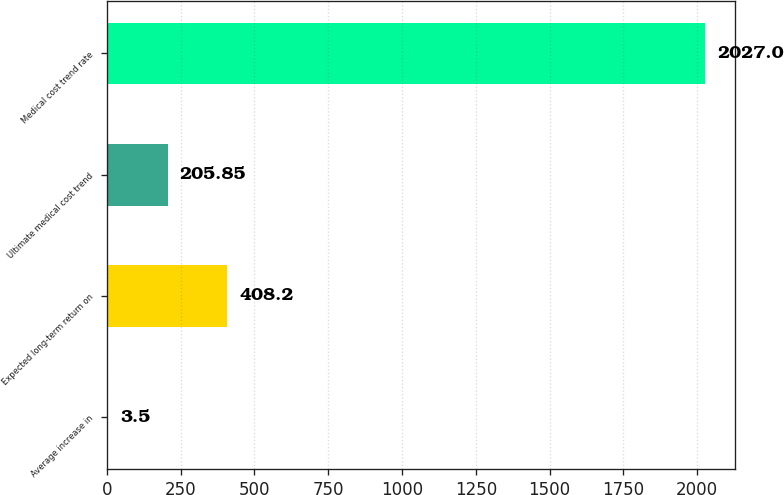<chart> <loc_0><loc_0><loc_500><loc_500><bar_chart><fcel>Average increase in<fcel>Expected long-term return on<fcel>Ultimate medical cost trend<fcel>Medical cost trend rate<nl><fcel>3.5<fcel>408.2<fcel>205.85<fcel>2027<nl></chart> 